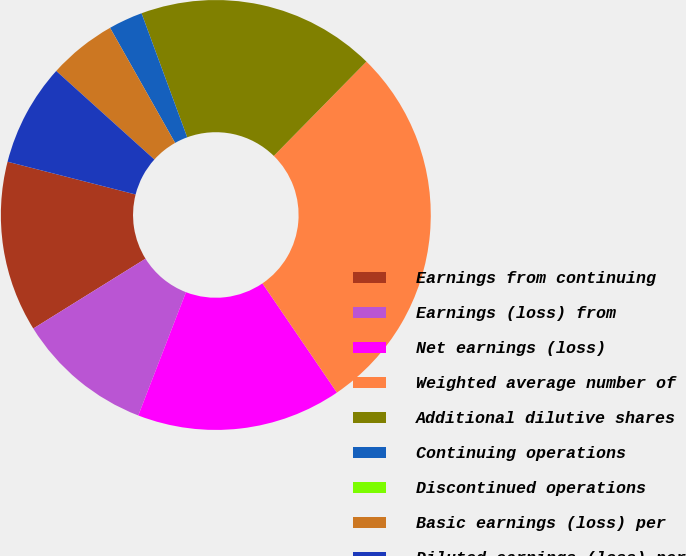Convert chart to OTSL. <chart><loc_0><loc_0><loc_500><loc_500><pie_chart><fcel>Earnings from continuing<fcel>Earnings (loss) from<fcel>Net earnings (loss)<fcel>Weighted average number of<fcel>Additional dilutive shares<fcel>Continuing operations<fcel>Discontinued operations<fcel>Basic earnings (loss) per<fcel>Diluted earnings (loss) per<nl><fcel>12.84%<fcel>10.27%<fcel>15.4%<fcel>28.12%<fcel>17.97%<fcel>2.57%<fcel>0.0%<fcel>5.13%<fcel>7.7%<nl></chart> 